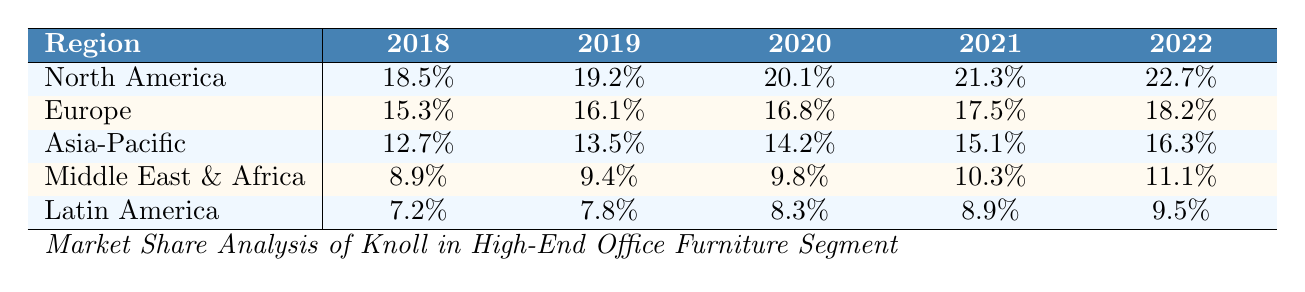What was Knoll's market share in North America in 2022? According to the table, the market share for North America in 2022 is listed as 22.7%.
Answer: 22.7% Which region had the lowest market share in 2018? By examining the table, we see that Latin America had the lowest market share in 2018, with a value of 7.2%.
Answer: Latin America What is the trend in Knoll's market share in Europe from 2018 to 2022? In the table, the market share values for Europe from 2018 to 2022 are 15.3%, 16.1%, 16.8%, 17.5%, and 18.2%. These values show a consistent increase over the years.
Answer: Increasing Which region saw the highest market share increase from 2018 to 2022? The increase for each region from 2018 to 2022 is calculated by subtracting the 2018 value from the 2022 value: North America (22.7 - 18.5 = 4.2), Europe (18.2 - 15.3 = 2.9), Asia-Pacific (16.3 - 12.7 = 3.6), Middle East & Africa (11.1 - 8.9 = 2.2), and Latin America (9.5 - 7.2 = 2.3). North America has the highest increase of 4.2%.
Answer: North America What is the average market share of Knoll in the Asia-Pacific region over the years? The market share values in the Asia-Pacific region from 2018 to 2022 are 12.7%, 13.5%, 14.2%, 15.1%, and 16.3%. Summing these values gives 12.7 + 13.5 + 14.2 + 15.1 + 16.3 = 71.8. There are 5 values, so the average is 71.8 / 5 = 14.36%.
Answer: 14.36% Is there any region where Knoll's market share remained the same over the years? By reviewing the table, we can see that no region had a constant market share over the years; every region showed an increase in market share.
Answer: No In which year did Knoll achieve the lowest market share in the Middle East & Africa? The table indicates that the lowest market share in the Middle East & Africa was in 2018, with a value of 8.9%.
Answer: 2018 What was the percentage increase in Knoll's market share in Latin America from 2018 to 2022? The market share for Latin America in 2018 was 7.2% and in 2022 was 9.5%. The increase is 9.5 - 7.2 = 2.3 percentage points. To find the percentage increase, we calculate (2.3 / 7.2) * 100 = 31.94%.
Answer: 31.94% Which year saw the highest recognition or award for Knoll? The table lists various awards from 2018 to 2022, and in 2020, Knoll received the Interior Design Best of Year Award for the Rockwell Unscripted Collection, which is a notable recognition. However, there’s no specific ranking, so it's subjective.
Answer: 2020 